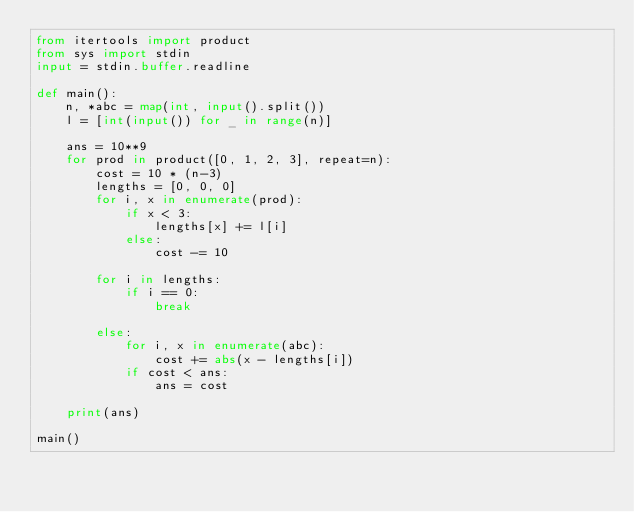Convert code to text. <code><loc_0><loc_0><loc_500><loc_500><_Python_>from itertools import product
from sys import stdin
input = stdin.buffer.readline

def main():
    n, *abc = map(int, input().split())
    l = [int(input()) for _ in range(n)]

    ans = 10**9
    for prod in product([0, 1, 2, 3], repeat=n):
        cost = 10 * (n-3)
        lengths = [0, 0, 0]
        for i, x in enumerate(prod):
            if x < 3:
                lengths[x] += l[i]
            else:
                cost -= 10

        for i in lengths:
            if i == 0:
                break

        else:
            for i, x in enumerate(abc):
                cost += abs(x - lengths[i])
            if cost < ans:
                ans = cost

    print(ans)

main()</code> 